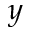<formula> <loc_0><loc_0><loc_500><loc_500>y</formula> 